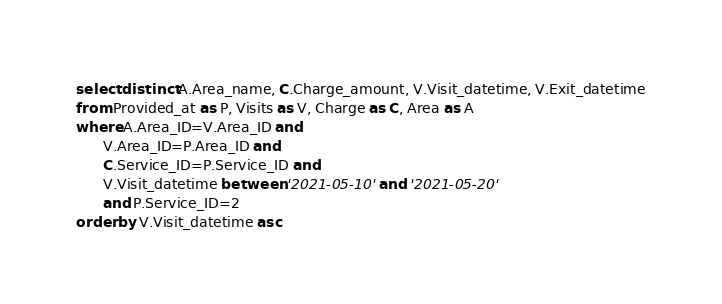<code> <loc_0><loc_0><loc_500><loc_500><_SQL_>select distinct A.Area_name, C.Charge_amount, V.Visit_datetime, V.Exit_datetime
from Provided_at as P, Visits as V, Charge as C, Area as A
where A.Area_ID=V.Area_ID and
	  V.Area_ID=P.Area_ID and 
	  C.Service_ID=P.Service_ID and
	  V.Visit_datetime between '2021-05-10' and '2021-05-20'
	  and P.Service_ID=2
order by V.Visit_datetime asc</code> 